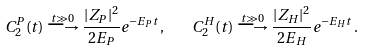Convert formula to latex. <formula><loc_0><loc_0><loc_500><loc_500>C _ { 2 } ^ { P } ( t ) \stackrel { t \gg 0 } { \longrightarrow } \frac { | Z _ { P } | ^ { 2 } } { 2 E _ { P } } e ^ { - E _ { P } t } \, , \quad C _ { 2 } ^ { H } ( t ) \stackrel { t \gg 0 } { \longrightarrow } \frac { | Z _ { H } | ^ { 2 } } { 2 E _ { H } } e ^ { - E _ { H } t } \, .</formula> 